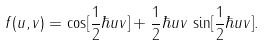Convert formula to latex. <formula><loc_0><loc_0><loc_500><loc_500>f ( u , v ) = \cos [ \frac { 1 } { 2 } \hbar { u } v ] + \frac { 1 } { 2 } \hbar { u } v \, \sin [ \frac { 1 } { 2 } \hbar { u } v ] .</formula> 